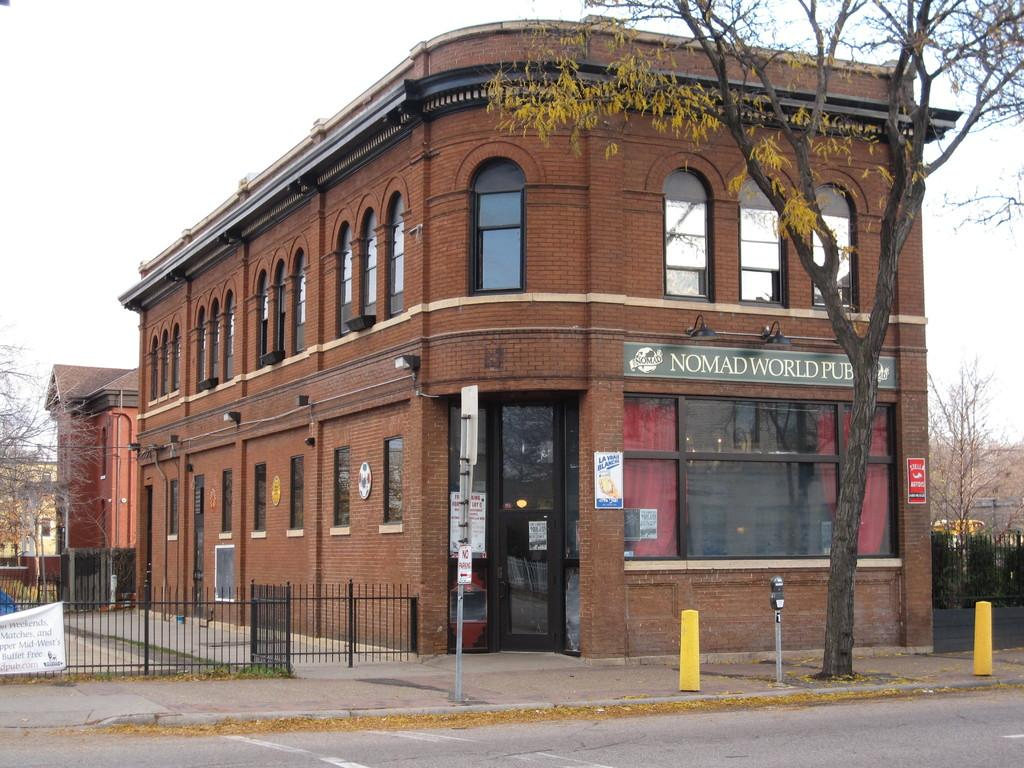What type of structures can be seen in the image? There are buildings in the image. What natural elements are present in the image? There are trees in the image. What type of barrier can be seen in the image? There is a fence in the image. What type of informational signs are present in the image? There are sign boards in the image. What type of construction materials are visible in the image? There are metal rods in the image. What type of illumination is present in the image? There are lights in the image. What type of weather is depicted in the image? The provided facts do not mention any weather conditions, so it cannot be determined from the image. Can you tell me what the father of the person who took the image looks like? The provided facts do not mention any individuals or their family members, so it cannot be determined from the image. 